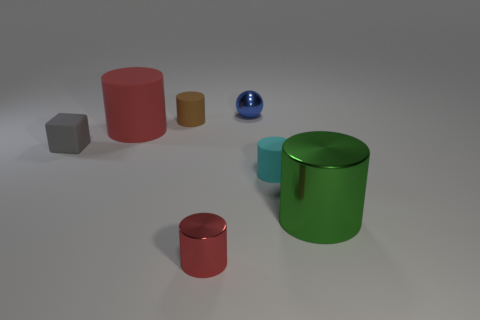Subtract all green blocks. How many red cylinders are left? 2 Subtract all big green cylinders. How many cylinders are left? 4 Subtract all cyan cylinders. How many cylinders are left? 4 Subtract all yellow cylinders. Subtract all purple balls. How many cylinders are left? 5 Add 1 small blue things. How many objects exist? 8 Subtract all cubes. How many objects are left? 6 Add 6 big red things. How many big red things exist? 7 Subtract 0 gray cylinders. How many objects are left? 7 Subtract all gray matte things. Subtract all tiny cubes. How many objects are left? 5 Add 3 gray blocks. How many gray blocks are left? 4 